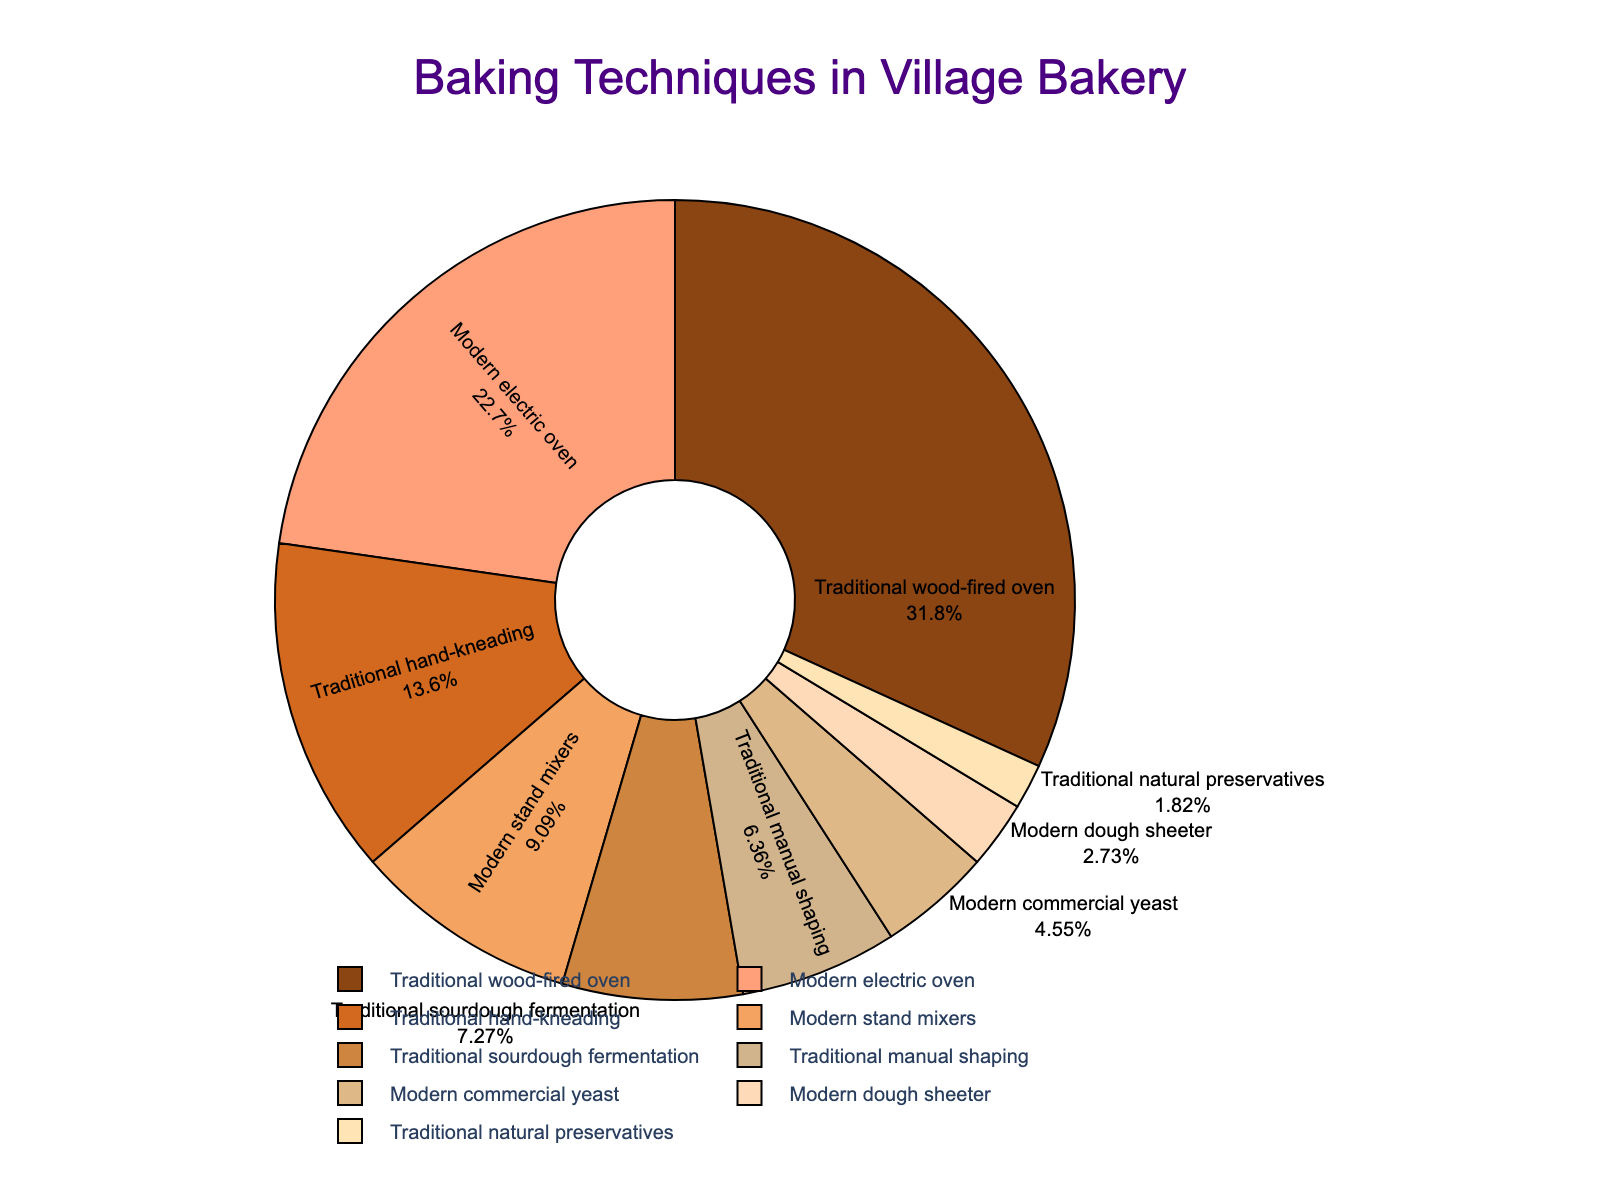What percentage of baking techniques used are modern? To find the percentage of modern techniques, sum the percentages of Modern electric oven (25%), Modern stand mixers (10%), Modern commercial yeast (5%), and Modern dough sheeter (3%). The total is 25 + 10 + 5 + 3 = 43%.
Answer: 43% Which traditional technique is used the most? By examining the percentages for traditional techniques, Traditional wood-fired oven has the highest percentage at 35%.
Answer: Traditional wood-fired oven How much more is the percentage of the Traditional wood-fired oven usage compared to the Modern electric oven usage? The percentage for Traditional wood-fired oven is 35%, while for Modern electric oven it is 25%. The difference is 35 - 25 = 10%.
Answer: 10% What is the least used technique among those listed? By examining the percentages, Traditional natural preservatives have the smallest share at 2%.
Answer: Traditional natural preservatives Is the combined percentage of all traditional techniques greater than 50%? The percentages for traditional techniques are summed as follows: 35% (Traditional wood-fired oven), 15% (Traditional hand-kneading), 8% (Traditional sourdough fermentation), 7% (Traditional manual shaping), and 2% (Traditional natural preservatives). The total is 35 + 15 + 8 + 7 + 2 = 67%, which is greater than 50%.
Answer: Yes Which technique uses the most modern technology in the baking process? By examining the modern techniques listed, Modern electric oven has the highest percentage at 25%.
Answer: Modern electric oven How does the percentage of Modern stand mixers compare to Traditional hand-kneading? Modern stand mixers are used 10% of the time, while Traditional hand-kneading is used 15% of the time. Therefore, Traditional hand-kneading is used more.
Answer: Traditional hand-kneading is used more How many traditional techniques are listed in the chart? From the given data, the traditional techniques listed are Traditional wood-fired oven, Traditional hand-kneading, Traditional sourdough fermentation, Traditional manual shaping, and Traditional natural preservatives, totaling 5.
Answer: 5 